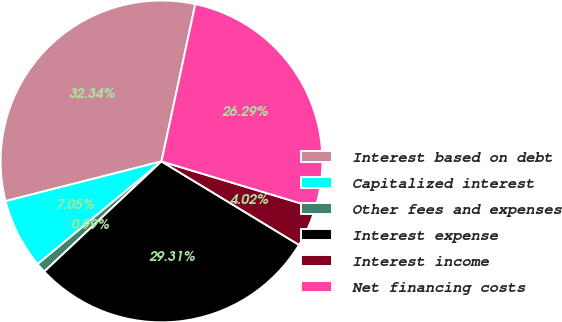Convert chart to OTSL. <chart><loc_0><loc_0><loc_500><loc_500><pie_chart><fcel>Interest based on debt<fcel>Capitalized interest<fcel>Other fees and expenses<fcel>Interest expense<fcel>Interest income<fcel>Net financing costs<nl><fcel>32.34%<fcel>7.05%<fcel>0.99%<fcel>29.31%<fcel>4.02%<fcel>26.29%<nl></chart> 